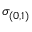<formula> <loc_0><loc_0><loc_500><loc_500>\sigma _ { ( 0 , 1 ) }</formula> 